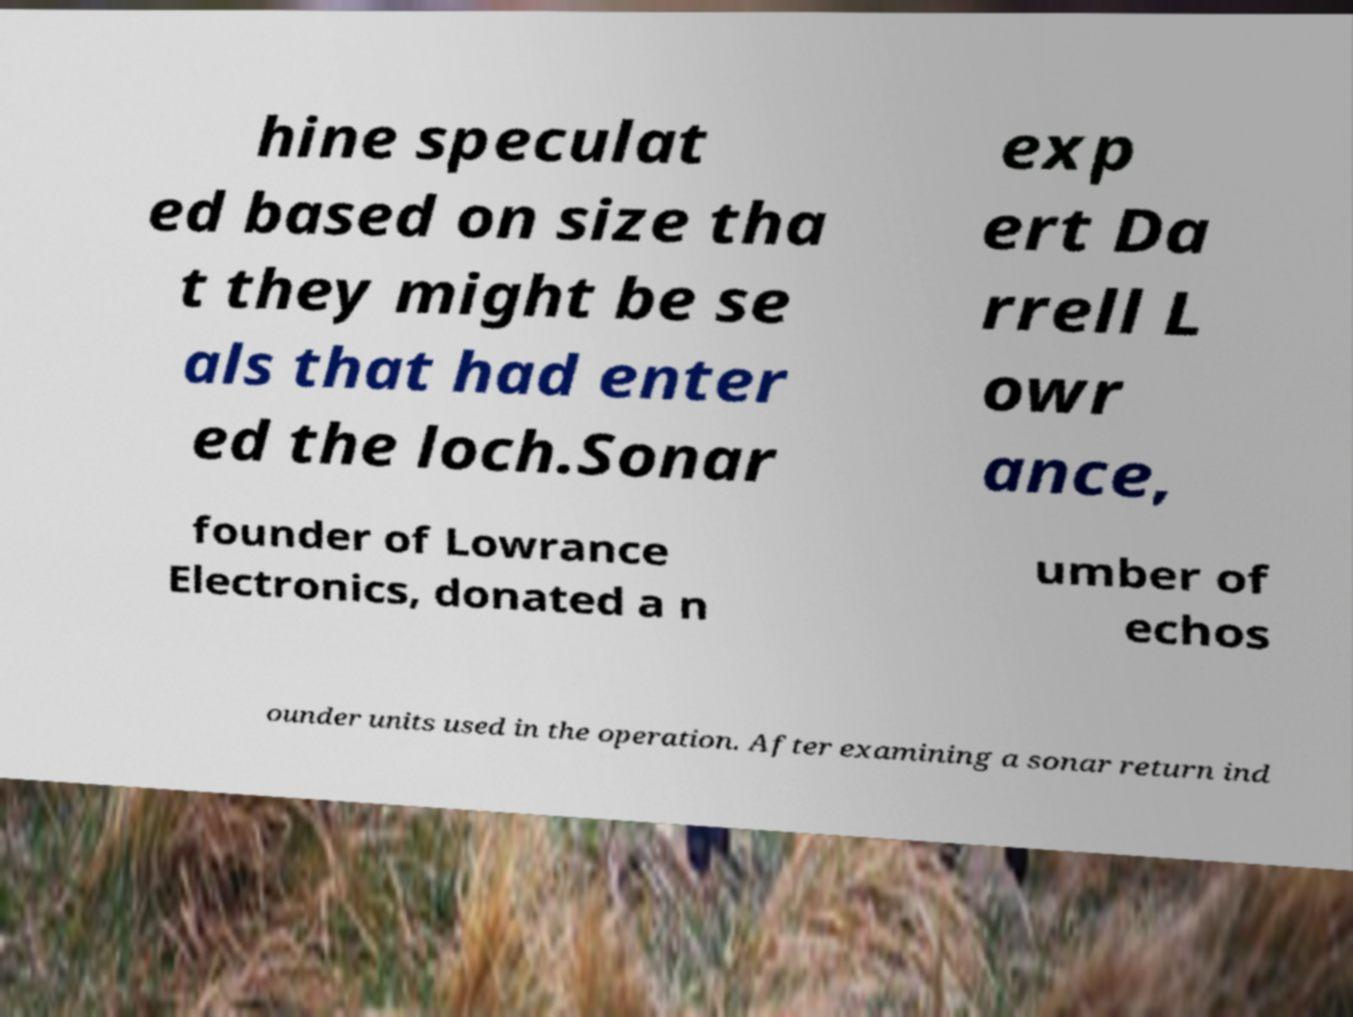There's text embedded in this image that I need extracted. Can you transcribe it verbatim? hine speculat ed based on size tha t they might be se als that had enter ed the loch.Sonar exp ert Da rrell L owr ance, founder of Lowrance Electronics, donated a n umber of echos ounder units used in the operation. After examining a sonar return ind 